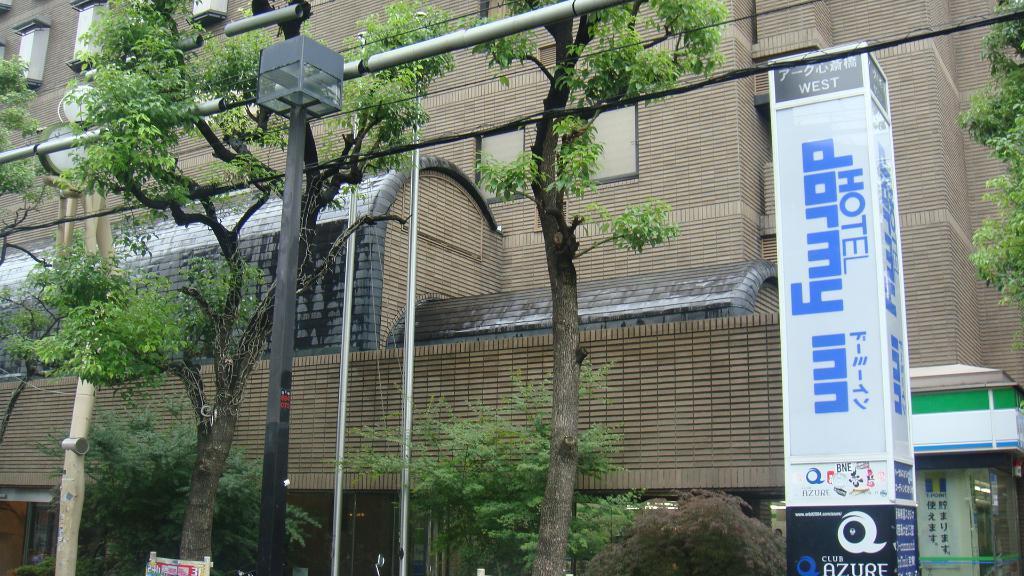In one or two sentences, can you explain what this image depicts? In this image I can see few poles, trees in green color and I can also see the board. In the background the building is in brown color. 